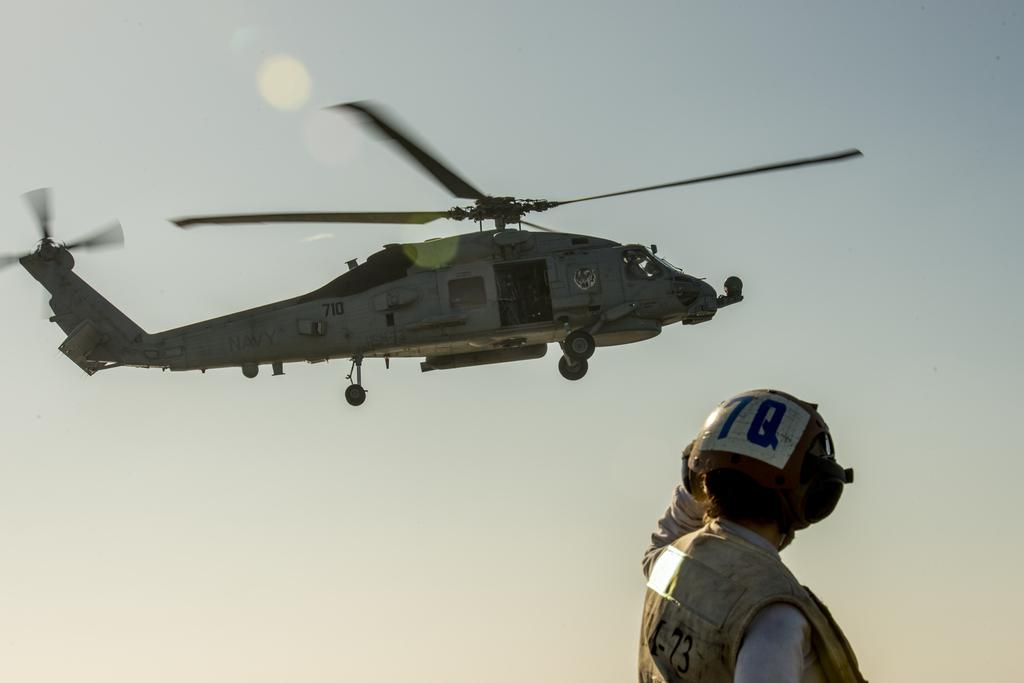Who or what is present on the right side at the bottom of the image? There is a person on the right side at the bottom of the image. Can you describe the person's position in relation to the image? The person is on the right side at the bottom of the image. What can be seen in the background of the image? There is a helicopter in the background of the image. How is the helicopter positioned in the image? The helicopter is flying in the sky in the background of the image. What type of gold jewelry is the boy wearing in the image? There is no boy or gold jewelry present in the image. 